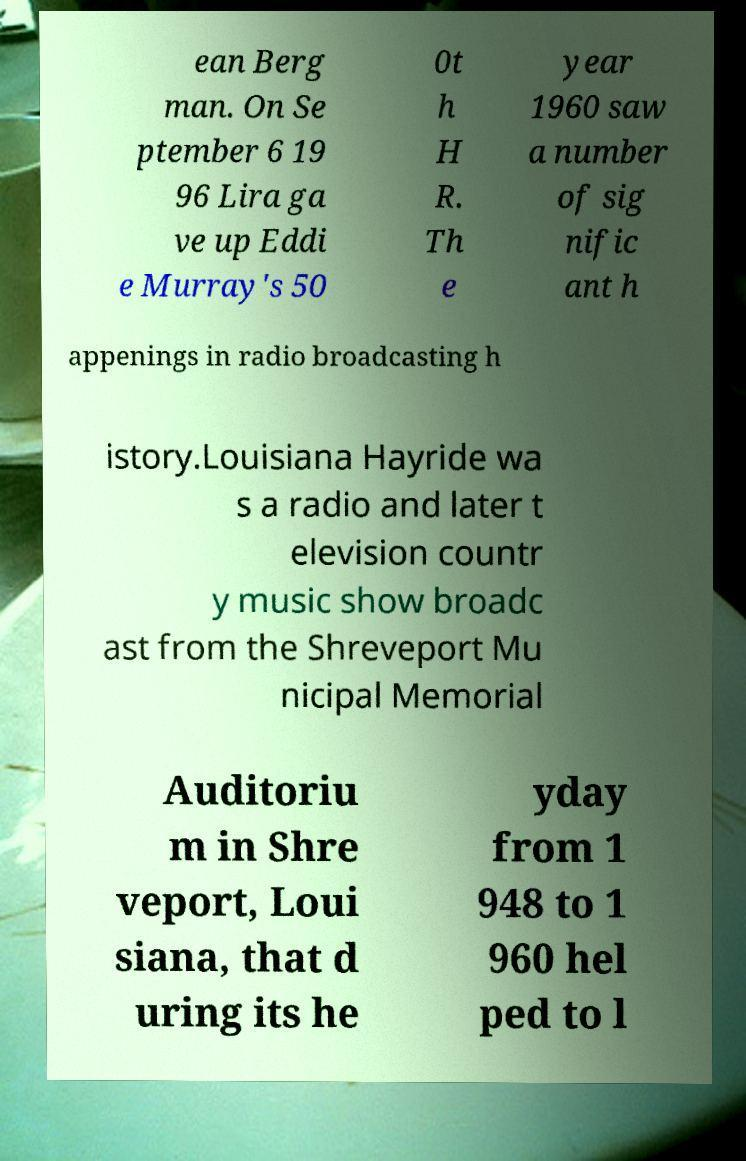Can you read and provide the text displayed in the image?This photo seems to have some interesting text. Can you extract and type it out for me? ean Berg man. On Se ptember 6 19 96 Lira ga ve up Eddi e Murray's 50 0t h H R. Th e year 1960 saw a number of sig nific ant h appenings in radio broadcasting h istory.Louisiana Hayride wa s a radio and later t elevision countr y music show broadc ast from the Shreveport Mu nicipal Memorial Auditoriu m in Shre veport, Loui siana, that d uring its he yday from 1 948 to 1 960 hel ped to l 